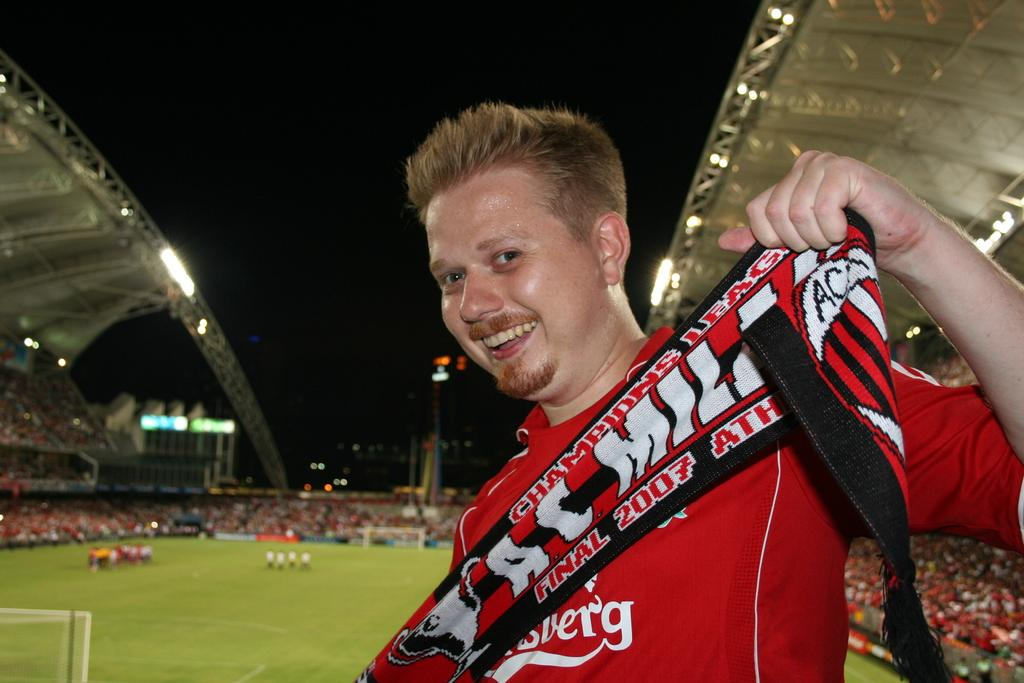<image>
Relay a brief, clear account of the picture shown. the word mill that is on a sign 